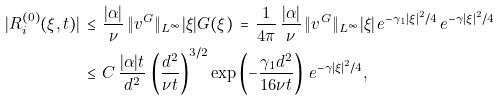Convert formula to latex. <formula><loc_0><loc_0><loc_500><loc_500>| R _ { i } ^ { ( 0 ) } ( \xi , t ) | \, & \leq \, \frac { | \alpha | } { \nu } \, \| v ^ { G } \| _ { L ^ { \infty } } | \xi | G ( \xi ) \, = \, \frac { 1 } { 4 \pi } \, \frac { | \alpha | } { \nu } \, \| v ^ { G } \| _ { L ^ { \infty } } | \xi | \, e ^ { - \gamma _ { 1 } | \xi | ^ { 2 } / 4 } \, e ^ { - \gamma | \xi | ^ { 2 } / 4 } \\ \, & \leq \, C \, \frac { | \alpha | t } { d ^ { 2 } } \, \left ( \frac { d ^ { 2 } } { \nu t } \right ) ^ { 3 / 2 } \exp \left ( - \frac { \gamma _ { 1 } d ^ { 2 } } { 1 6 \nu t } \right ) \, e ^ { - \gamma | \xi | ^ { 2 } / 4 } ,</formula> 